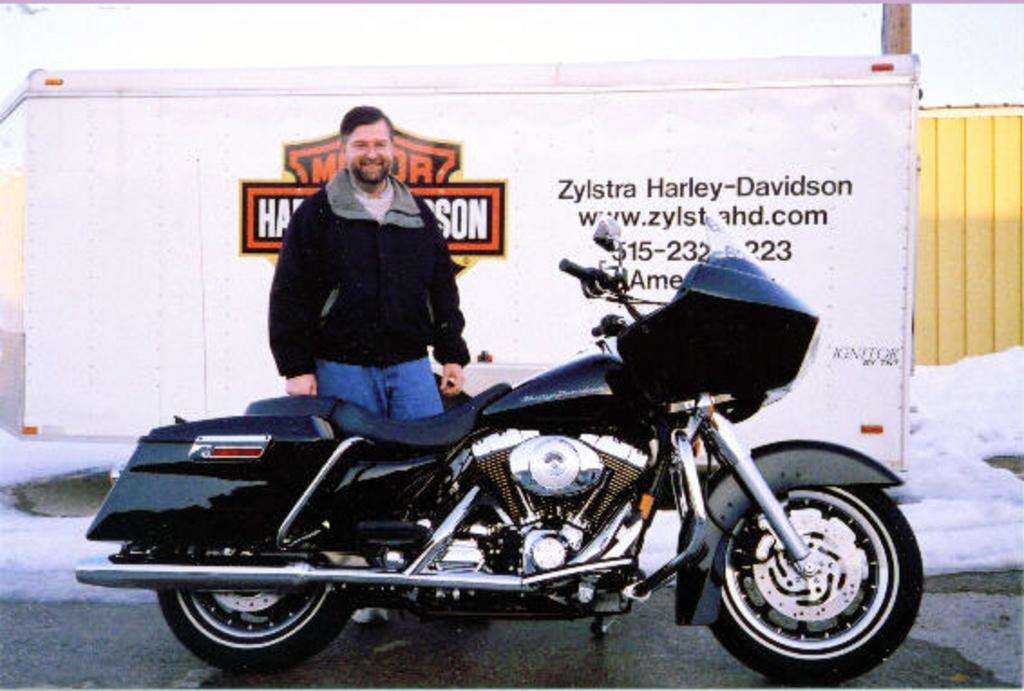What is the main subject of the image? The main subject of the image is a bike on a road. Who or what is present near the bike? There is a man standing behind the bike. What can be seen in the background of the image? There is a board in the background of the image. What is written on the board? There is text on the board. What is the weather like in the image? There is snow visible in the image, indicating a cold or wintry setting. What type of crime is being committed in the image? There is no indication of a crime being committed in the image; it features a bike, a man, a board, and snow. Can you tell me how many swings are present in the image? There are no swings present in the image; it features a bike, a man, a board, and snow. 